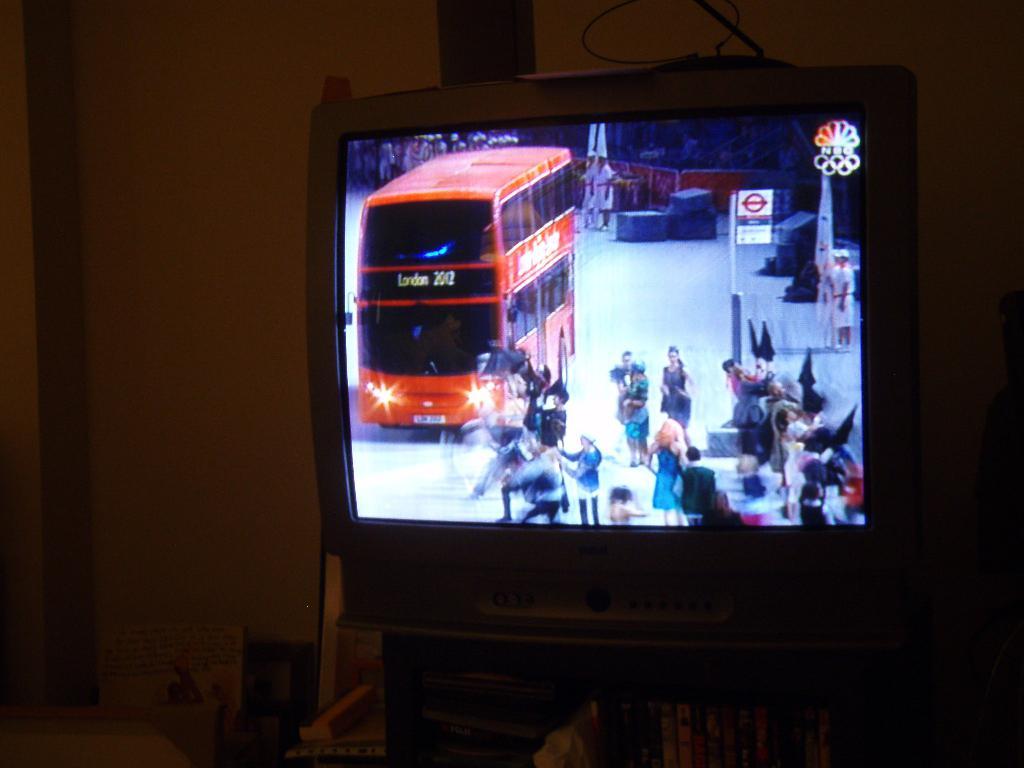What tv channel is in the top right corner?
Give a very brief answer. Nbc. 